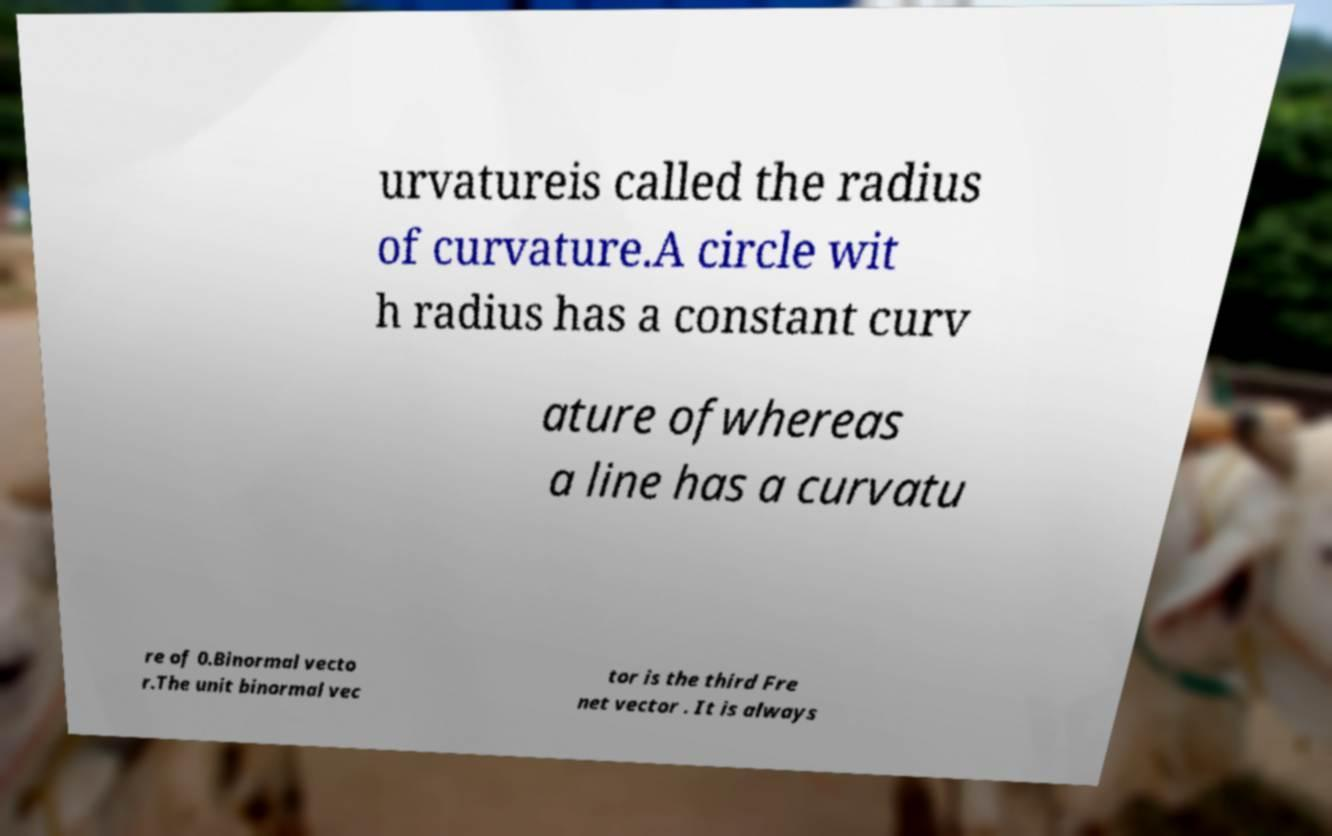Can you read and provide the text displayed in the image?This photo seems to have some interesting text. Can you extract and type it out for me? urvatureis called the radius of curvature.A circle wit h radius has a constant curv ature ofwhereas a line has a curvatu re of 0.Binormal vecto r.The unit binormal vec tor is the third Fre net vector . It is always 